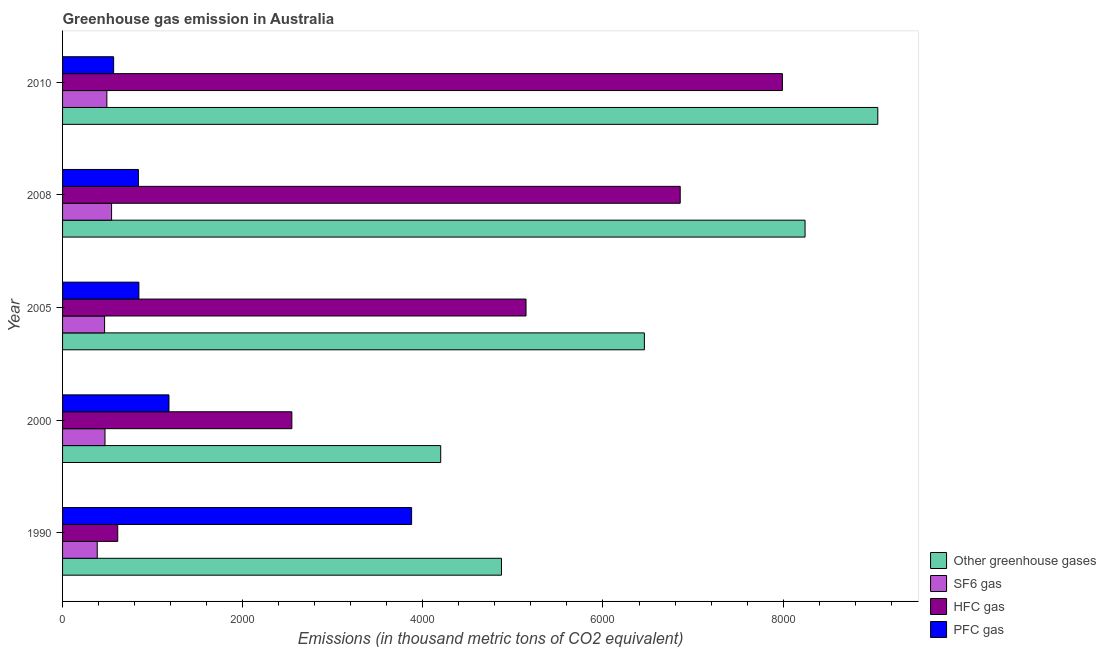How many different coloured bars are there?
Give a very brief answer. 4. How many groups of bars are there?
Your response must be concise. 5. Are the number of bars per tick equal to the number of legend labels?
Your answer should be compact. Yes. How many bars are there on the 4th tick from the top?
Your answer should be compact. 4. What is the label of the 4th group of bars from the top?
Make the answer very short. 2000. In how many cases, is the number of bars for a given year not equal to the number of legend labels?
Provide a short and direct response. 0. What is the emission of pfc gas in 1990?
Provide a succinct answer. 3875.2. Across all years, what is the maximum emission of greenhouse gases?
Ensure brevity in your answer.  9051. Across all years, what is the minimum emission of greenhouse gases?
Give a very brief answer. 4198.3. In which year was the emission of hfc gas maximum?
Ensure brevity in your answer.  2010. In which year was the emission of hfc gas minimum?
Offer a terse response. 1990. What is the total emission of sf6 gas in the graph?
Make the answer very short. 2359. What is the difference between the emission of hfc gas in 2000 and that in 2010?
Give a very brief answer. -5446.3. What is the difference between the emission of sf6 gas in 2010 and the emission of hfc gas in 2005?
Make the answer very short. -4653.6. What is the average emission of hfc gas per year?
Your response must be concise. 4630.64. In the year 1990, what is the difference between the emission of hfc gas and emission of pfc gas?
Your response must be concise. -3262.7. In how many years, is the emission of hfc gas greater than 7200 thousand metric tons?
Keep it short and to the point. 1. What is the ratio of the emission of greenhouse gases in 1990 to that in 2010?
Make the answer very short. 0.54. Is the difference between the emission of hfc gas in 1990 and 2010 greater than the difference between the emission of pfc gas in 1990 and 2010?
Provide a short and direct response. No. What is the difference between the highest and the second highest emission of sf6 gas?
Offer a very short reply. 52.1. What is the difference between the highest and the lowest emission of pfc gas?
Provide a short and direct response. 3308.2. In how many years, is the emission of sf6 gas greater than the average emission of sf6 gas taken over all years?
Your response must be concise. 2. Is the sum of the emission of hfc gas in 1990 and 2010 greater than the maximum emission of greenhouse gases across all years?
Your answer should be compact. No. Is it the case that in every year, the sum of the emission of pfc gas and emission of greenhouse gases is greater than the sum of emission of hfc gas and emission of sf6 gas?
Keep it short and to the point. Yes. What does the 4th bar from the top in 1990 represents?
Keep it short and to the point. Other greenhouse gases. What does the 3rd bar from the bottom in 2008 represents?
Your response must be concise. HFC gas. Is it the case that in every year, the sum of the emission of greenhouse gases and emission of sf6 gas is greater than the emission of hfc gas?
Your response must be concise. Yes. How many bars are there?
Make the answer very short. 20. How many years are there in the graph?
Ensure brevity in your answer.  5. Does the graph contain grids?
Your response must be concise. No. How many legend labels are there?
Keep it short and to the point. 4. How are the legend labels stacked?
Make the answer very short. Vertical. What is the title of the graph?
Offer a terse response. Greenhouse gas emission in Australia. Does "Bird species" appear as one of the legend labels in the graph?
Offer a very short reply. No. What is the label or title of the X-axis?
Your answer should be compact. Emissions (in thousand metric tons of CO2 equivalent). What is the Emissions (in thousand metric tons of CO2 equivalent) of Other greenhouse gases in 1990?
Offer a terse response. 4872.8. What is the Emissions (in thousand metric tons of CO2 equivalent) of SF6 gas in 1990?
Provide a succinct answer. 385.1. What is the Emissions (in thousand metric tons of CO2 equivalent) of HFC gas in 1990?
Your response must be concise. 612.5. What is the Emissions (in thousand metric tons of CO2 equivalent) in PFC gas in 1990?
Provide a succinct answer. 3875.2. What is the Emissions (in thousand metric tons of CO2 equivalent) in Other greenhouse gases in 2000?
Make the answer very short. 4198.3. What is the Emissions (in thousand metric tons of CO2 equivalent) in SF6 gas in 2000?
Ensure brevity in your answer.  471.2. What is the Emissions (in thousand metric tons of CO2 equivalent) in HFC gas in 2000?
Keep it short and to the point. 2545.7. What is the Emissions (in thousand metric tons of CO2 equivalent) in PFC gas in 2000?
Ensure brevity in your answer.  1181.4. What is the Emissions (in thousand metric tons of CO2 equivalent) of Other greenhouse gases in 2005?
Provide a short and direct response. 6459.6. What is the Emissions (in thousand metric tons of CO2 equivalent) in SF6 gas in 2005?
Give a very brief answer. 466.6. What is the Emissions (in thousand metric tons of CO2 equivalent) in HFC gas in 2005?
Ensure brevity in your answer.  5145.6. What is the Emissions (in thousand metric tons of CO2 equivalent) of PFC gas in 2005?
Offer a terse response. 847.4. What is the Emissions (in thousand metric tons of CO2 equivalent) of Other greenhouse gases in 2008?
Provide a succinct answer. 8243.5. What is the Emissions (in thousand metric tons of CO2 equivalent) of SF6 gas in 2008?
Offer a very short reply. 544.1. What is the Emissions (in thousand metric tons of CO2 equivalent) of HFC gas in 2008?
Offer a terse response. 6857.4. What is the Emissions (in thousand metric tons of CO2 equivalent) in PFC gas in 2008?
Keep it short and to the point. 842. What is the Emissions (in thousand metric tons of CO2 equivalent) in Other greenhouse gases in 2010?
Your answer should be compact. 9051. What is the Emissions (in thousand metric tons of CO2 equivalent) in SF6 gas in 2010?
Offer a very short reply. 492. What is the Emissions (in thousand metric tons of CO2 equivalent) in HFC gas in 2010?
Your answer should be very brief. 7992. What is the Emissions (in thousand metric tons of CO2 equivalent) in PFC gas in 2010?
Make the answer very short. 567. Across all years, what is the maximum Emissions (in thousand metric tons of CO2 equivalent) in Other greenhouse gases?
Keep it short and to the point. 9051. Across all years, what is the maximum Emissions (in thousand metric tons of CO2 equivalent) of SF6 gas?
Provide a succinct answer. 544.1. Across all years, what is the maximum Emissions (in thousand metric tons of CO2 equivalent) in HFC gas?
Keep it short and to the point. 7992. Across all years, what is the maximum Emissions (in thousand metric tons of CO2 equivalent) in PFC gas?
Your response must be concise. 3875.2. Across all years, what is the minimum Emissions (in thousand metric tons of CO2 equivalent) of Other greenhouse gases?
Your answer should be compact. 4198.3. Across all years, what is the minimum Emissions (in thousand metric tons of CO2 equivalent) of SF6 gas?
Provide a succinct answer. 385.1. Across all years, what is the minimum Emissions (in thousand metric tons of CO2 equivalent) in HFC gas?
Make the answer very short. 612.5. Across all years, what is the minimum Emissions (in thousand metric tons of CO2 equivalent) in PFC gas?
Give a very brief answer. 567. What is the total Emissions (in thousand metric tons of CO2 equivalent) in Other greenhouse gases in the graph?
Provide a short and direct response. 3.28e+04. What is the total Emissions (in thousand metric tons of CO2 equivalent) of SF6 gas in the graph?
Your response must be concise. 2359. What is the total Emissions (in thousand metric tons of CO2 equivalent) in HFC gas in the graph?
Offer a terse response. 2.32e+04. What is the total Emissions (in thousand metric tons of CO2 equivalent) in PFC gas in the graph?
Provide a short and direct response. 7313. What is the difference between the Emissions (in thousand metric tons of CO2 equivalent) of Other greenhouse gases in 1990 and that in 2000?
Provide a short and direct response. 674.5. What is the difference between the Emissions (in thousand metric tons of CO2 equivalent) of SF6 gas in 1990 and that in 2000?
Your answer should be compact. -86.1. What is the difference between the Emissions (in thousand metric tons of CO2 equivalent) in HFC gas in 1990 and that in 2000?
Keep it short and to the point. -1933.2. What is the difference between the Emissions (in thousand metric tons of CO2 equivalent) in PFC gas in 1990 and that in 2000?
Your answer should be very brief. 2693.8. What is the difference between the Emissions (in thousand metric tons of CO2 equivalent) in Other greenhouse gases in 1990 and that in 2005?
Your answer should be compact. -1586.8. What is the difference between the Emissions (in thousand metric tons of CO2 equivalent) in SF6 gas in 1990 and that in 2005?
Provide a short and direct response. -81.5. What is the difference between the Emissions (in thousand metric tons of CO2 equivalent) of HFC gas in 1990 and that in 2005?
Give a very brief answer. -4533.1. What is the difference between the Emissions (in thousand metric tons of CO2 equivalent) in PFC gas in 1990 and that in 2005?
Ensure brevity in your answer.  3027.8. What is the difference between the Emissions (in thousand metric tons of CO2 equivalent) in Other greenhouse gases in 1990 and that in 2008?
Your answer should be compact. -3370.7. What is the difference between the Emissions (in thousand metric tons of CO2 equivalent) of SF6 gas in 1990 and that in 2008?
Your answer should be very brief. -159. What is the difference between the Emissions (in thousand metric tons of CO2 equivalent) of HFC gas in 1990 and that in 2008?
Your answer should be compact. -6244.9. What is the difference between the Emissions (in thousand metric tons of CO2 equivalent) of PFC gas in 1990 and that in 2008?
Offer a terse response. 3033.2. What is the difference between the Emissions (in thousand metric tons of CO2 equivalent) in Other greenhouse gases in 1990 and that in 2010?
Offer a terse response. -4178.2. What is the difference between the Emissions (in thousand metric tons of CO2 equivalent) of SF6 gas in 1990 and that in 2010?
Provide a short and direct response. -106.9. What is the difference between the Emissions (in thousand metric tons of CO2 equivalent) in HFC gas in 1990 and that in 2010?
Offer a very short reply. -7379.5. What is the difference between the Emissions (in thousand metric tons of CO2 equivalent) in PFC gas in 1990 and that in 2010?
Give a very brief answer. 3308.2. What is the difference between the Emissions (in thousand metric tons of CO2 equivalent) of Other greenhouse gases in 2000 and that in 2005?
Offer a very short reply. -2261.3. What is the difference between the Emissions (in thousand metric tons of CO2 equivalent) in SF6 gas in 2000 and that in 2005?
Your answer should be very brief. 4.6. What is the difference between the Emissions (in thousand metric tons of CO2 equivalent) of HFC gas in 2000 and that in 2005?
Keep it short and to the point. -2599.9. What is the difference between the Emissions (in thousand metric tons of CO2 equivalent) of PFC gas in 2000 and that in 2005?
Keep it short and to the point. 334. What is the difference between the Emissions (in thousand metric tons of CO2 equivalent) of Other greenhouse gases in 2000 and that in 2008?
Provide a succinct answer. -4045.2. What is the difference between the Emissions (in thousand metric tons of CO2 equivalent) of SF6 gas in 2000 and that in 2008?
Ensure brevity in your answer.  -72.9. What is the difference between the Emissions (in thousand metric tons of CO2 equivalent) of HFC gas in 2000 and that in 2008?
Your answer should be compact. -4311.7. What is the difference between the Emissions (in thousand metric tons of CO2 equivalent) in PFC gas in 2000 and that in 2008?
Offer a very short reply. 339.4. What is the difference between the Emissions (in thousand metric tons of CO2 equivalent) of Other greenhouse gases in 2000 and that in 2010?
Your response must be concise. -4852.7. What is the difference between the Emissions (in thousand metric tons of CO2 equivalent) in SF6 gas in 2000 and that in 2010?
Your response must be concise. -20.8. What is the difference between the Emissions (in thousand metric tons of CO2 equivalent) in HFC gas in 2000 and that in 2010?
Give a very brief answer. -5446.3. What is the difference between the Emissions (in thousand metric tons of CO2 equivalent) in PFC gas in 2000 and that in 2010?
Offer a very short reply. 614.4. What is the difference between the Emissions (in thousand metric tons of CO2 equivalent) of Other greenhouse gases in 2005 and that in 2008?
Ensure brevity in your answer.  -1783.9. What is the difference between the Emissions (in thousand metric tons of CO2 equivalent) in SF6 gas in 2005 and that in 2008?
Give a very brief answer. -77.5. What is the difference between the Emissions (in thousand metric tons of CO2 equivalent) of HFC gas in 2005 and that in 2008?
Ensure brevity in your answer.  -1711.8. What is the difference between the Emissions (in thousand metric tons of CO2 equivalent) of Other greenhouse gases in 2005 and that in 2010?
Give a very brief answer. -2591.4. What is the difference between the Emissions (in thousand metric tons of CO2 equivalent) in SF6 gas in 2005 and that in 2010?
Offer a terse response. -25.4. What is the difference between the Emissions (in thousand metric tons of CO2 equivalent) in HFC gas in 2005 and that in 2010?
Keep it short and to the point. -2846.4. What is the difference between the Emissions (in thousand metric tons of CO2 equivalent) of PFC gas in 2005 and that in 2010?
Offer a terse response. 280.4. What is the difference between the Emissions (in thousand metric tons of CO2 equivalent) of Other greenhouse gases in 2008 and that in 2010?
Provide a succinct answer. -807.5. What is the difference between the Emissions (in thousand metric tons of CO2 equivalent) of SF6 gas in 2008 and that in 2010?
Your answer should be compact. 52.1. What is the difference between the Emissions (in thousand metric tons of CO2 equivalent) of HFC gas in 2008 and that in 2010?
Offer a very short reply. -1134.6. What is the difference between the Emissions (in thousand metric tons of CO2 equivalent) of PFC gas in 2008 and that in 2010?
Your response must be concise. 275. What is the difference between the Emissions (in thousand metric tons of CO2 equivalent) in Other greenhouse gases in 1990 and the Emissions (in thousand metric tons of CO2 equivalent) in SF6 gas in 2000?
Provide a succinct answer. 4401.6. What is the difference between the Emissions (in thousand metric tons of CO2 equivalent) in Other greenhouse gases in 1990 and the Emissions (in thousand metric tons of CO2 equivalent) in HFC gas in 2000?
Provide a succinct answer. 2327.1. What is the difference between the Emissions (in thousand metric tons of CO2 equivalent) in Other greenhouse gases in 1990 and the Emissions (in thousand metric tons of CO2 equivalent) in PFC gas in 2000?
Your response must be concise. 3691.4. What is the difference between the Emissions (in thousand metric tons of CO2 equivalent) of SF6 gas in 1990 and the Emissions (in thousand metric tons of CO2 equivalent) of HFC gas in 2000?
Make the answer very short. -2160.6. What is the difference between the Emissions (in thousand metric tons of CO2 equivalent) in SF6 gas in 1990 and the Emissions (in thousand metric tons of CO2 equivalent) in PFC gas in 2000?
Your answer should be compact. -796.3. What is the difference between the Emissions (in thousand metric tons of CO2 equivalent) of HFC gas in 1990 and the Emissions (in thousand metric tons of CO2 equivalent) of PFC gas in 2000?
Your answer should be very brief. -568.9. What is the difference between the Emissions (in thousand metric tons of CO2 equivalent) of Other greenhouse gases in 1990 and the Emissions (in thousand metric tons of CO2 equivalent) of SF6 gas in 2005?
Ensure brevity in your answer.  4406.2. What is the difference between the Emissions (in thousand metric tons of CO2 equivalent) in Other greenhouse gases in 1990 and the Emissions (in thousand metric tons of CO2 equivalent) in HFC gas in 2005?
Your answer should be compact. -272.8. What is the difference between the Emissions (in thousand metric tons of CO2 equivalent) of Other greenhouse gases in 1990 and the Emissions (in thousand metric tons of CO2 equivalent) of PFC gas in 2005?
Your answer should be compact. 4025.4. What is the difference between the Emissions (in thousand metric tons of CO2 equivalent) of SF6 gas in 1990 and the Emissions (in thousand metric tons of CO2 equivalent) of HFC gas in 2005?
Ensure brevity in your answer.  -4760.5. What is the difference between the Emissions (in thousand metric tons of CO2 equivalent) of SF6 gas in 1990 and the Emissions (in thousand metric tons of CO2 equivalent) of PFC gas in 2005?
Your answer should be compact. -462.3. What is the difference between the Emissions (in thousand metric tons of CO2 equivalent) of HFC gas in 1990 and the Emissions (in thousand metric tons of CO2 equivalent) of PFC gas in 2005?
Ensure brevity in your answer.  -234.9. What is the difference between the Emissions (in thousand metric tons of CO2 equivalent) in Other greenhouse gases in 1990 and the Emissions (in thousand metric tons of CO2 equivalent) in SF6 gas in 2008?
Offer a very short reply. 4328.7. What is the difference between the Emissions (in thousand metric tons of CO2 equivalent) in Other greenhouse gases in 1990 and the Emissions (in thousand metric tons of CO2 equivalent) in HFC gas in 2008?
Provide a succinct answer. -1984.6. What is the difference between the Emissions (in thousand metric tons of CO2 equivalent) in Other greenhouse gases in 1990 and the Emissions (in thousand metric tons of CO2 equivalent) in PFC gas in 2008?
Make the answer very short. 4030.8. What is the difference between the Emissions (in thousand metric tons of CO2 equivalent) of SF6 gas in 1990 and the Emissions (in thousand metric tons of CO2 equivalent) of HFC gas in 2008?
Provide a succinct answer. -6472.3. What is the difference between the Emissions (in thousand metric tons of CO2 equivalent) of SF6 gas in 1990 and the Emissions (in thousand metric tons of CO2 equivalent) of PFC gas in 2008?
Provide a succinct answer. -456.9. What is the difference between the Emissions (in thousand metric tons of CO2 equivalent) of HFC gas in 1990 and the Emissions (in thousand metric tons of CO2 equivalent) of PFC gas in 2008?
Give a very brief answer. -229.5. What is the difference between the Emissions (in thousand metric tons of CO2 equivalent) in Other greenhouse gases in 1990 and the Emissions (in thousand metric tons of CO2 equivalent) in SF6 gas in 2010?
Your answer should be compact. 4380.8. What is the difference between the Emissions (in thousand metric tons of CO2 equivalent) in Other greenhouse gases in 1990 and the Emissions (in thousand metric tons of CO2 equivalent) in HFC gas in 2010?
Your answer should be very brief. -3119.2. What is the difference between the Emissions (in thousand metric tons of CO2 equivalent) in Other greenhouse gases in 1990 and the Emissions (in thousand metric tons of CO2 equivalent) in PFC gas in 2010?
Provide a short and direct response. 4305.8. What is the difference between the Emissions (in thousand metric tons of CO2 equivalent) of SF6 gas in 1990 and the Emissions (in thousand metric tons of CO2 equivalent) of HFC gas in 2010?
Offer a very short reply. -7606.9. What is the difference between the Emissions (in thousand metric tons of CO2 equivalent) of SF6 gas in 1990 and the Emissions (in thousand metric tons of CO2 equivalent) of PFC gas in 2010?
Give a very brief answer. -181.9. What is the difference between the Emissions (in thousand metric tons of CO2 equivalent) of HFC gas in 1990 and the Emissions (in thousand metric tons of CO2 equivalent) of PFC gas in 2010?
Your answer should be very brief. 45.5. What is the difference between the Emissions (in thousand metric tons of CO2 equivalent) of Other greenhouse gases in 2000 and the Emissions (in thousand metric tons of CO2 equivalent) of SF6 gas in 2005?
Your response must be concise. 3731.7. What is the difference between the Emissions (in thousand metric tons of CO2 equivalent) of Other greenhouse gases in 2000 and the Emissions (in thousand metric tons of CO2 equivalent) of HFC gas in 2005?
Offer a very short reply. -947.3. What is the difference between the Emissions (in thousand metric tons of CO2 equivalent) of Other greenhouse gases in 2000 and the Emissions (in thousand metric tons of CO2 equivalent) of PFC gas in 2005?
Keep it short and to the point. 3350.9. What is the difference between the Emissions (in thousand metric tons of CO2 equivalent) of SF6 gas in 2000 and the Emissions (in thousand metric tons of CO2 equivalent) of HFC gas in 2005?
Your answer should be compact. -4674.4. What is the difference between the Emissions (in thousand metric tons of CO2 equivalent) of SF6 gas in 2000 and the Emissions (in thousand metric tons of CO2 equivalent) of PFC gas in 2005?
Provide a succinct answer. -376.2. What is the difference between the Emissions (in thousand metric tons of CO2 equivalent) in HFC gas in 2000 and the Emissions (in thousand metric tons of CO2 equivalent) in PFC gas in 2005?
Your answer should be compact. 1698.3. What is the difference between the Emissions (in thousand metric tons of CO2 equivalent) of Other greenhouse gases in 2000 and the Emissions (in thousand metric tons of CO2 equivalent) of SF6 gas in 2008?
Offer a very short reply. 3654.2. What is the difference between the Emissions (in thousand metric tons of CO2 equivalent) of Other greenhouse gases in 2000 and the Emissions (in thousand metric tons of CO2 equivalent) of HFC gas in 2008?
Offer a very short reply. -2659.1. What is the difference between the Emissions (in thousand metric tons of CO2 equivalent) in Other greenhouse gases in 2000 and the Emissions (in thousand metric tons of CO2 equivalent) in PFC gas in 2008?
Your response must be concise. 3356.3. What is the difference between the Emissions (in thousand metric tons of CO2 equivalent) of SF6 gas in 2000 and the Emissions (in thousand metric tons of CO2 equivalent) of HFC gas in 2008?
Your answer should be compact. -6386.2. What is the difference between the Emissions (in thousand metric tons of CO2 equivalent) in SF6 gas in 2000 and the Emissions (in thousand metric tons of CO2 equivalent) in PFC gas in 2008?
Give a very brief answer. -370.8. What is the difference between the Emissions (in thousand metric tons of CO2 equivalent) of HFC gas in 2000 and the Emissions (in thousand metric tons of CO2 equivalent) of PFC gas in 2008?
Offer a very short reply. 1703.7. What is the difference between the Emissions (in thousand metric tons of CO2 equivalent) in Other greenhouse gases in 2000 and the Emissions (in thousand metric tons of CO2 equivalent) in SF6 gas in 2010?
Make the answer very short. 3706.3. What is the difference between the Emissions (in thousand metric tons of CO2 equivalent) of Other greenhouse gases in 2000 and the Emissions (in thousand metric tons of CO2 equivalent) of HFC gas in 2010?
Offer a terse response. -3793.7. What is the difference between the Emissions (in thousand metric tons of CO2 equivalent) of Other greenhouse gases in 2000 and the Emissions (in thousand metric tons of CO2 equivalent) of PFC gas in 2010?
Provide a succinct answer. 3631.3. What is the difference between the Emissions (in thousand metric tons of CO2 equivalent) in SF6 gas in 2000 and the Emissions (in thousand metric tons of CO2 equivalent) in HFC gas in 2010?
Offer a terse response. -7520.8. What is the difference between the Emissions (in thousand metric tons of CO2 equivalent) of SF6 gas in 2000 and the Emissions (in thousand metric tons of CO2 equivalent) of PFC gas in 2010?
Make the answer very short. -95.8. What is the difference between the Emissions (in thousand metric tons of CO2 equivalent) of HFC gas in 2000 and the Emissions (in thousand metric tons of CO2 equivalent) of PFC gas in 2010?
Provide a short and direct response. 1978.7. What is the difference between the Emissions (in thousand metric tons of CO2 equivalent) in Other greenhouse gases in 2005 and the Emissions (in thousand metric tons of CO2 equivalent) in SF6 gas in 2008?
Offer a very short reply. 5915.5. What is the difference between the Emissions (in thousand metric tons of CO2 equivalent) in Other greenhouse gases in 2005 and the Emissions (in thousand metric tons of CO2 equivalent) in HFC gas in 2008?
Make the answer very short. -397.8. What is the difference between the Emissions (in thousand metric tons of CO2 equivalent) in Other greenhouse gases in 2005 and the Emissions (in thousand metric tons of CO2 equivalent) in PFC gas in 2008?
Make the answer very short. 5617.6. What is the difference between the Emissions (in thousand metric tons of CO2 equivalent) of SF6 gas in 2005 and the Emissions (in thousand metric tons of CO2 equivalent) of HFC gas in 2008?
Make the answer very short. -6390.8. What is the difference between the Emissions (in thousand metric tons of CO2 equivalent) of SF6 gas in 2005 and the Emissions (in thousand metric tons of CO2 equivalent) of PFC gas in 2008?
Provide a short and direct response. -375.4. What is the difference between the Emissions (in thousand metric tons of CO2 equivalent) in HFC gas in 2005 and the Emissions (in thousand metric tons of CO2 equivalent) in PFC gas in 2008?
Offer a terse response. 4303.6. What is the difference between the Emissions (in thousand metric tons of CO2 equivalent) of Other greenhouse gases in 2005 and the Emissions (in thousand metric tons of CO2 equivalent) of SF6 gas in 2010?
Your answer should be very brief. 5967.6. What is the difference between the Emissions (in thousand metric tons of CO2 equivalent) in Other greenhouse gases in 2005 and the Emissions (in thousand metric tons of CO2 equivalent) in HFC gas in 2010?
Your response must be concise. -1532.4. What is the difference between the Emissions (in thousand metric tons of CO2 equivalent) of Other greenhouse gases in 2005 and the Emissions (in thousand metric tons of CO2 equivalent) of PFC gas in 2010?
Offer a terse response. 5892.6. What is the difference between the Emissions (in thousand metric tons of CO2 equivalent) of SF6 gas in 2005 and the Emissions (in thousand metric tons of CO2 equivalent) of HFC gas in 2010?
Offer a very short reply. -7525.4. What is the difference between the Emissions (in thousand metric tons of CO2 equivalent) in SF6 gas in 2005 and the Emissions (in thousand metric tons of CO2 equivalent) in PFC gas in 2010?
Your answer should be compact. -100.4. What is the difference between the Emissions (in thousand metric tons of CO2 equivalent) in HFC gas in 2005 and the Emissions (in thousand metric tons of CO2 equivalent) in PFC gas in 2010?
Offer a terse response. 4578.6. What is the difference between the Emissions (in thousand metric tons of CO2 equivalent) in Other greenhouse gases in 2008 and the Emissions (in thousand metric tons of CO2 equivalent) in SF6 gas in 2010?
Make the answer very short. 7751.5. What is the difference between the Emissions (in thousand metric tons of CO2 equivalent) of Other greenhouse gases in 2008 and the Emissions (in thousand metric tons of CO2 equivalent) of HFC gas in 2010?
Make the answer very short. 251.5. What is the difference between the Emissions (in thousand metric tons of CO2 equivalent) in Other greenhouse gases in 2008 and the Emissions (in thousand metric tons of CO2 equivalent) in PFC gas in 2010?
Your answer should be very brief. 7676.5. What is the difference between the Emissions (in thousand metric tons of CO2 equivalent) of SF6 gas in 2008 and the Emissions (in thousand metric tons of CO2 equivalent) of HFC gas in 2010?
Your response must be concise. -7447.9. What is the difference between the Emissions (in thousand metric tons of CO2 equivalent) of SF6 gas in 2008 and the Emissions (in thousand metric tons of CO2 equivalent) of PFC gas in 2010?
Your answer should be compact. -22.9. What is the difference between the Emissions (in thousand metric tons of CO2 equivalent) in HFC gas in 2008 and the Emissions (in thousand metric tons of CO2 equivalent) in PFC gas in 2010?
Ensure brevity in your answer.  6290.4. What is the average Emissions (in thousand metric tons of CO2 equivalent) of Other greenhouse gases per year?
Give a very brief answer. 6565.04. What is the average Emissions (in thousand metric tons of CO2 equivalent) in SF6 gas per year?
Your answer should be compact. 471.8. What is the average Emissions (in thousand metric tons of CO2 equivalent) in HFC gas per year?
Provide a short and direct response. 4630.64. What is the average Emissions (in thousand metric tons of CO2 equivalent) in PFC gas per year?
Your answer should be compact. 1462.6. In the year 1990, what is the difference between the Emissions (in thousand metric tons of CO2 equivalent) of Other greenhouse gases and Emissions (in thousand metric tons of CO2 equivalent) of SF6 gas?
Your response must be concise. 4487.7. In the year 1990, what is the difference between the Emissions (in thousand metric tons of CO2 equivalent) in Other greenhouse gases and Emissions (in thousand metric tons of CO2 equivalent) in HFC gas?
Offer a terse response. 4260.3. In the year 1990, what is the difference between the Emissions (in thousand metric tons of CO2 equivalent) in Other greenhouse gases and Emissions (in thousand metric tons of CO2 equivalent) in PFC gas?
Your answer should be compact. 997.6. In the year 1990, what is the difference between the Emissions (in thousand metric tons of CO2 equivalent) of SF6 gas and Emissions (in thousand metric tons of CO2 equivalent) of HFC gas?
Give a very brief answer. -227.4. In the year 1990, what is the difference between the Emissions (in thousand metric tons of CO2 equivalent) in SF6 gas and Emissions (in thousand metric tons of CO2 equivalent) in PFC gas?
Offer a terse response. -3490.1. In the year 1990, what is the difference between the Emissions (in thousand metric tons of CO2 equivalent) in HFC gas and Emissions (in thousand metric tons of CO2 equivalent) in PFC gas?
Provide a short and direct response. -3262.7. In the year 2000, what is the difference between the Emissions (in thousand metric tons of CO2 equivalent) in Other greenhouse gases and Emissions (in thousand metric tons of CO2 equivalent) in SF6 gas?
Keep it short and to the point. 3727.1. In the year 2000, what is the difference between the Emissions (in thousand metric tons of CO2 equivalent) of Other greenhouse gases and Emissions (in thousand metric tons of CO2 equivalent) of HFC gas?
Provide a short and direct response. 1652.6. In the year 2000, what is the difference between the Emissions (in thousand metric tons of CO2 equivalent) of Other greenhouse gases and Emissions (in thousand metric tons of CO2 equivalent) of PFC gas?
Give a very brief answer. 3016.9. In the year 2000, what is the difference between the Emissions (in thousand metric tons of CO2 equivalent) in SF6 gas and Emissions (in thousand metric tons of CO2 equivalent) in HFC gas?
Ensure brevity in your answer.  -2074.5. In the year 2000, what is the difference between the Emissions (in thousand metric tons of CO2 equivalent) in SF6 gas and Emissions (in thousand metric tons of CO2 equivalent) in PFC gas?
Offer a terse response. -710.2. In the year 2000, what is the difference between the Emissions (in thousand metric tons of CO2 equivalent) in HFC gas and Emissions (in thousand metric tons of CO2 equivalent) in PFC gas?
Your answer should be compact. 1364.3. In the year 2005, what is the difference between the Emissions (in thousand metric tons of CO2 equivalent) of Other greenhouse gases and Emissions (in thousand metric tons of CO2 equivalent) of SF6 gas?
Make the answer very short. 5993. In the year 2005, what is the difference between the Emissions (in thousand metric tons of CO2 equivalent) of Other greenhouse gases and Emissions (in thousand metric tons of CO2 equivalent) of HFC gas?
Your answer should be very brief. 1314. In the year 2005, what is the difference between the Emissions (in thousand metric tons of CO2 equivalent) of Other greenhouse gases and Emissions (in thousand metric tons of CO2 equivalent) of PFC gas?
Your answer should be compact. 5612.2. In the year 2005, what is the difference between the Emissions (in thousand metric tons of CO2 equivalent) of SF6 gas and Emissions (in thousand metric tons of CO2 equivalent) of HFC gas?
Provide a succinct answer. -4679. In the year 2005, what is the difference between the Emissions (in thousand metric tons of CO2 equivalent) of SF6 gas and Emissions (in thousand metric tons of CO2 equivalent) of PFC gas?
Provide a short and direct response. -380.8. In the year 2005, what is the difference between the Emissions (in thousand metric tons of CO2 equivalent) of HFC gas and Emissions (in thousand metric tons of CO2 equivalent) of PFC gas?
Make the answer very short. 4298.2. In the year 2008, what is the difference between the Emissions (in thousand metric tons of CO2 equivalent) of Other greenhouse gases and Emissions (in thousand metric tons of CO2 equivalent) of SF6 gas?
Offer a terse response. 7699.4. In the year 2008, what is the difference between the Emissions (in thousand metric tons of CO2 equivalent) of Other greenhouse gases and Emissions (in thousand metric tons of CO2 equivalent) of HFC gas?
Your answer should be very brief. 1386.1. In the year 2008, what is the difference between the Emissions (in thousand metric tons of CO2 equivalent) in Other greenhouse gases and Emissions (in thousand metric tons of CO2 equivalent) in PFC gas?
Your answer should be very brief. 7401.5. In the year 2008, what is the difference between the Emissions (in thousand metric tons of CO2 equivalent) of SF6 gas and Emissions (in thousand metric tons of CO2 equivalent) of HFC gas?
Your answer should be compact. -6313.3. In the year 2008, what is the difference between the Emissions (in thousand metric tons of CO2 equivalent) of SF6 gas and Emissions (in thousand metric tons of CO2 equivalent) of PFC gas?
Offer a terse response. -297.9. In the year 2008, what is the difference between the Emissions (in thousand metric tons of CO2 equivalent) in HFC gas and Emissions (in thousand metric tons of CO2 equivalent) in PFC gas?
Make the answer very short. 6015.4. In the year 2010, what is the difference between the Emissions (in thousand metric tons of CO2 equivalent) of Other greenhouse gases and Emissions (in thousand metric tons of CO2 equivalent) of SF6 gas?
Provide a short and direct response. 8559. In the year 2010, what is the difference between the Emissions (in thousand metric tons of CO2 equivalent) of Other greenhouse gases and Emissions (in thousand metric tons of CO2 equivalent) of HFC gas?
Provide a short and direct response. 1059. In the year 2010, what is the difference between the Emissions (in thousand metric tons of CO2 equivalent) in Other greenhouse gases and Emissions (in thousand metric tons of CO2 equivalent) in PFC gas?
Your response must be concise. 8484. In the year 2010, what is the difference between the Emissions (in thousand metric tons of CO2 equivalent) in SF6 gas and Emissions (in thousand metric tons of CO2 equivalent) in HFC gas?
Offer a very short reply. -7500. In the year 2010, what is the difference between the Emissions (in thousand metric tons of CO2 equivalent) of SF6 gas and Emissions (in thousand metric tons of CO2 equivalent) of PFC gas?
Keep it short and to the point. -75. In the year 2010, what is the difference between the Emissions (in thousand metric tons of CO2 equivalent) in HFC gas and Emissions (in thousand metric tons of CO2 equivalent) in PFC gas?
Your response must be concise. 7425. What is the ratio of the Emissions (in thousand metric tons of CO2 equivalent) in Other greenhouse gases in 1990 to that in 2000?
Keep it short and to the point. 1.16. What is the ratio of the Emissions (in thousand metric tons of CO2 equivalent) in SF6 gas in 1990 to that in 2000?
Ensure brevity in your answer.  0.82. What is the ratio of the Emissions (in thousand metric tons of CO2 equivalent) of HFC gas in 1990 to that in 2000?
Ensure brevity in your answer.  0.24. What is the ratio of the Emissions (in thousand metric tons of CO2 equivalent) in PFC gas in 1990 to that in 2000?
Make the answer very short. 3.28. What is the ratio of the Emissions (in thousand metric tons of CO2 equivalent) of Other greenhouse gases in 1990 to that in 2005?
Provide a short and direct response. 0.75. What is the ratio of the Emissions (in thousand metric tons of CO2 equivalent) in SF6 gas in 1990 to that in 2005?
Offer a terse response. 0.83. What is the ratio of the Emissions (in thousand metric tons of CO2 equivalent) of HFC gas in 1990 to that in 2005?
Your response must be concise. 0.12. What is the ratio of the Emissions (in thousand metric tons of CO2 equivalent) in PFC gas in 1990 to that in 2005?
Ensure brevity in your answer.  4.57. What is the ratio of the Emissions (in thousand metric tons of CO2 equivalent) in Other greenhouse gases in 1990 to that in 2008?
Offer a terse response. 0.59. What is the ratio of the Emissions (in thousand metric tons of CO2 equivalent) in SF6 gas in 1990 to that in 2008?
Offer a terse response. 0.71. What is the ratio of the Emissions (in thousand metric tons of CO2 equivalent) of HFC gas in 1990 to that in 2008?
Provide a short and direct response. 0.09. What is the ratio of the Emissions (in thousand metric tons of CO2 equivalent) in PFC gas in 1990 to that in 2008?
Provide a succinct answer. 4.6. What is the ratio of the Emissions (in thousand metric tons of CO2 equivalent) of Other greenhouse gases in 1990 to that in 2010?
Offer a terse response. 0.54. What is the ratio of the Emissions (in thousand metric tons of CO2 equivalent) in SF6 gas in 1990 to that in 2010?
Your response must be concise. 0.78. What is the ratio of the Emissions (in thousand metric tons of CO2 equivalent) of HFC gas in 1990 to that in 2010?
Ensure brevity in your answer.  0.08. What is the ratio of the Emissions (in thousand metric tons of CO2 equivalent) of PFC gas in 1990 to that in 2010?
Your answer should be compact. 6.83. What is the ratio of the Emissions (in thousand metric tons of CO2 equivalent) of Other greenhouse gases in 2000 to that in 2005?
Make the answer very short. 0.65. What is the ratio of the Emissions (in thousand metric tons of CO2 equivalent) of SF6 gas in 2000 to that in 2005?
Give a very brief answer. 1.01. What is the ratio of the Emissions (in thousand metric tons of CO2 equivalent) of HFC gas in 2000 to that in 2005?
Provide a succinct answer. 0.49. What is the ratio of the Emissions (in thousand metric tons of CO2 equivalent) in PFC gas in 2000 to that in 2005?
Provide a succinct answer. 1.39. What is the ratio of the Emissions (in thousand metric tons of CO2 equivalent) of Other greenhouse gases in 2000 to that in 2008?
Your answer should be very brief. 0.51. What is the ratio of the Emissions (in thousand metric tons of CO2 equivalent) in SF6 gas in 2000 to that in 2008?
Make the answer very short. 0.87. What is the ratio of the Emissions (in thousand metric tons of CO2 equivalent) in HFC gas in 2000 to that in 2008?
Make the answer very short. 0.37. What is the ratio of the Emissions (in thousand metric tons of CO2 equivalent) of PFC gas in 2000 to that in 2008?
Give a very brief answer. 1.4. What is the ratio of the Emissions (in thousand metric tons of CO2 equivalent) of Other greenhouse gases in 2000 to that in 2010?
Provide a short and direct response. 0.46. What is the ratio of the Emissions (in thousand metric tons of CO2 equivalent) in SF6 gas in 2000 to that in 2010?
Provide a short and direct response. 0.96. What is the ratio of the Emissions (in thousand metric tons of CO2 equivalent) in HFC gas in 2000 to that in 2010?
Ensure brevity in your answer.  0.32. What is the ratio of the Emissions (in thousand metric tons of CO2 equivalent) of PFC gas in 2000 to that in 2010?
Offer a terse response. 2.08. What is the ratio of the Emissions (in thousand metric tons of CO2 equivalent) of Other greenhouse gases in 2005 to that in 2008?
Your answer should be compact. 0.78. What is the ratio of the Emissions (in thousand metric tons of CO2 equivalent) in SF6 gas in 2005 to that in 2008?
Keep it short and to the point. 0.86. What is the ratio of the Emissions (in thousand metric tons of CO2 equivalent) of HFC gas in 2005 to that in 2008?
Give a very brief answer. 0.75. What is the ratio of the Emissions (in thousand metric tons of CO2 equivalent) of PFC gas in 2005 to that in 2008?
Your answer should be compact. 1.01. What is the ratio of the Emissions (in thousand metric tons of CO2 equivalent) of Other greenhouse gases in 2005 to that in 2010?
Your response must be concise. 0.71. What is the ratio of the Emissions (in thousand metric tons of CO2 equivalent) in SF6 gas in 2005 to that in 2010?
Your answer should be compact. 0.95. What is the ratio of the Emissions (in thousand metric tons of CO2 equivalent) in HFC gas in 2005 to that in 2010?
Provide a short and direct response. 0.64. What is the ratio of the Emissions (in thousand metric tons of CO2 equivalent) of PFC gas in 2005 to that in 2010?
Give a very brief answer. 1.49. What is the ratio of the Emissions (in thousand metric tons of CO2 equivalent) of Other greenhouse gases in 2008 to that in 2010?
Your answer should be compact. 0.91. What is the ratio of the Emissions (in thousand metric tons of CO2 equivalent) of SF6 gas in 2008 to that in 2010?
Provide a succinct answer. 1.11. What is the ratio of the Emissions (in thousand metric tons of CO2 equivalent) in HFC gas in 2008 to that in 2010?
Ensure brevity in your answer.  0.86. What is the ratio of the Emissions (in thousand metric tons of CO2 equivalent) in PFC gas in 2008 to that in 2010?
Offer a terse response. 1.49. What is the difference between the highest and the second highest Emissions (in thousand metric tons of CO2 equivalent) in Other greenhouse gases?
Provide a succinct answer. 807.5. What is the difference between the highest and the second highest Emissions (in thousand metric tons of CO2 equivalent) of SF6 gas?
Provide a short and direct response. 52.1. What is the difference between the highest and the second highest Emissions (in thousand metric tons of CO2 equivalent) of HFC gas?
Provide a succinct answer. 1134.6. What is the difference between the highest and the second highest Emissions (in thousand metric tons of CO2 equivalent) in PFC gas?
Give a very brief answer. 2693.8. What is the difference between the highest and the lowest Emissions (in thousand metric tons of CO2 equivalent) in Other greenhouse gases?
Ensure brevity in your answer.  4852.7. What is the difference between the highest and the lowest Emissions (in thousand metric tons of CO2 equivalent) in SF6 gas?
Make the answer very short. 159. What is the difference between the highest and the lowest Emissions (in thousand metric tons of CO2 equivalent) of HFC gas?
Make the answer very short. 7379.5. What is the difference between the highest and the lowest Emissions (in thousand metric tons of CO2 equivalent) in PFC gas?
Your answer should be very brief. 3308.2. 